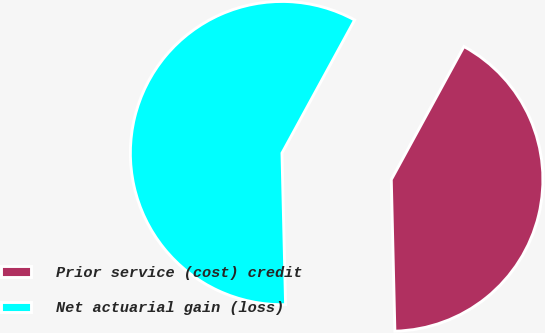Convert chart. <chart><loc_0><loc_0><loc_500><loc_500><pie_chart><fcel>Prior service (cost) credit<fcel>Net actuarial gain (loss)<nl><fcel>41.67%<fcel>58.33%<nl></chart> 